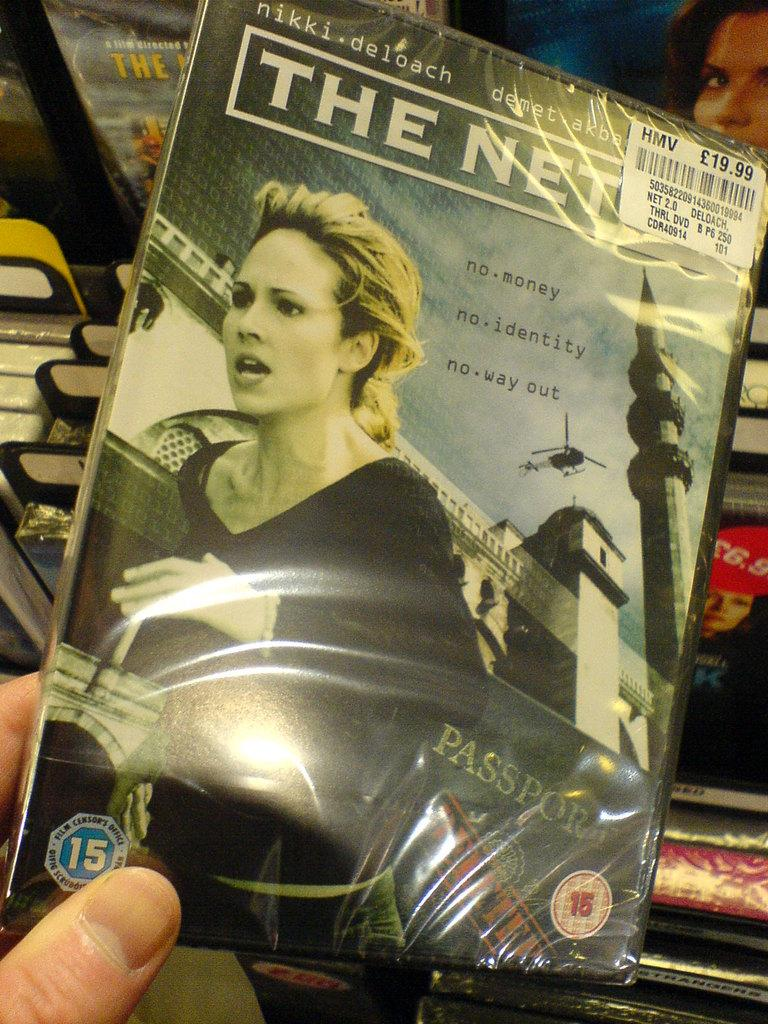<image>
Write a terse but informative summary of the picture. a shrink wrapped copy of the film the net 